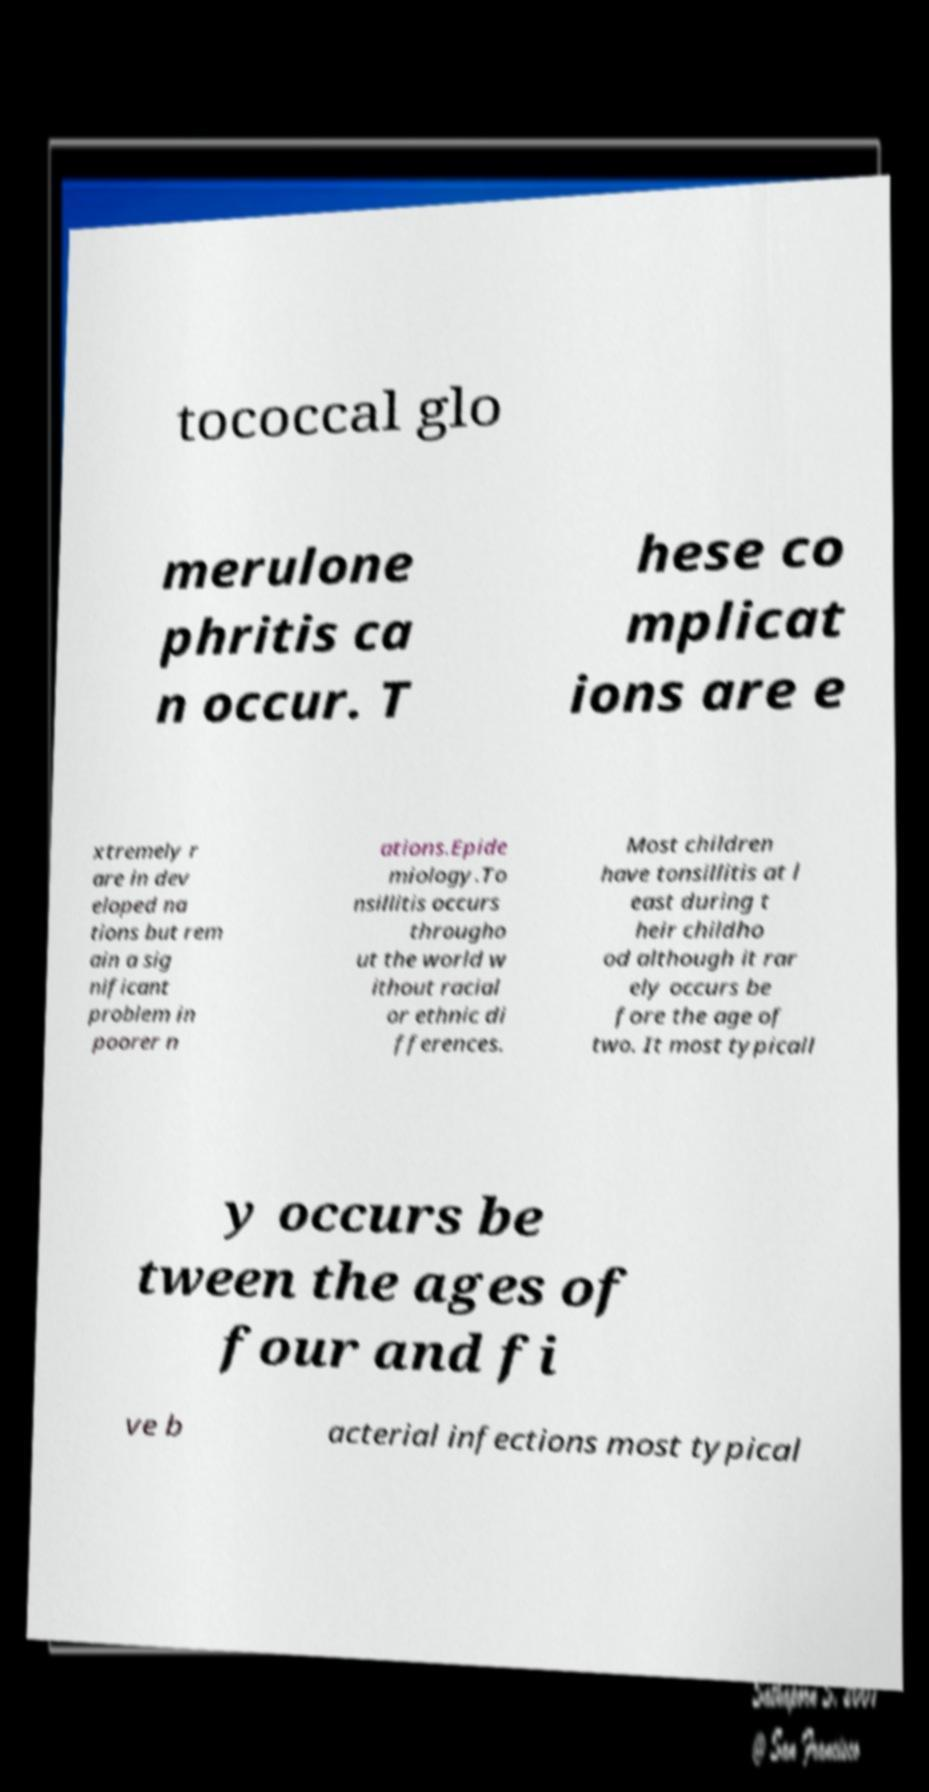Can you read and provide the text displayed in the image?This photo seems to have some interesting text. Can you extract and type it out for me? tococcal glo merulone phritis ca n occur. T hese co mplicat ions are e xtremely r are in dev eloped na tions but rem ain a sig nificant problem in poorer n ations.Epide miology.To nsillitis occurs througho ut the world w ithout racial or ethnic di fferences. Most children have tonsillitis at l east during t heir childho od although it rar ely occurs be fore the age of two. It most typicall y occurs be tween the ages of four and fi ve b acterial infections most typical 